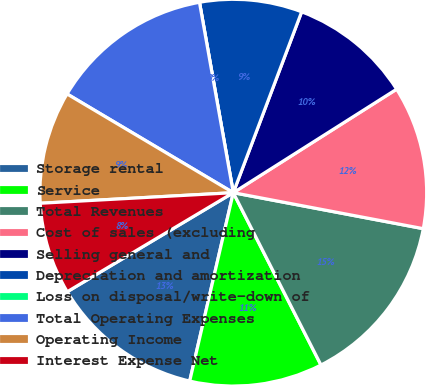<chart> <loc_0><loc_0><loc_500><loc_500><pie_chart><fcel>Storage rental<fcel>Service<fcel>Total Revenues<fcel>Cost of sales (excluding<fcel>Selling general and<fcel>Depreciation and amortization<fcel>Loss on disposal/write-down of<fcel>Total Operating Expenses<fcel>Operating Income<fcel>Interest Expense Net<nl><fcel>12.82%<fcel>11.11%<fcel>14.53%<fcel>11.97%<fcel>10.26%<fcel>8.55%<fcel>0.0%<fcel>13.67%<fcel>9.4%<fcel>7.69%<nl></chart> 